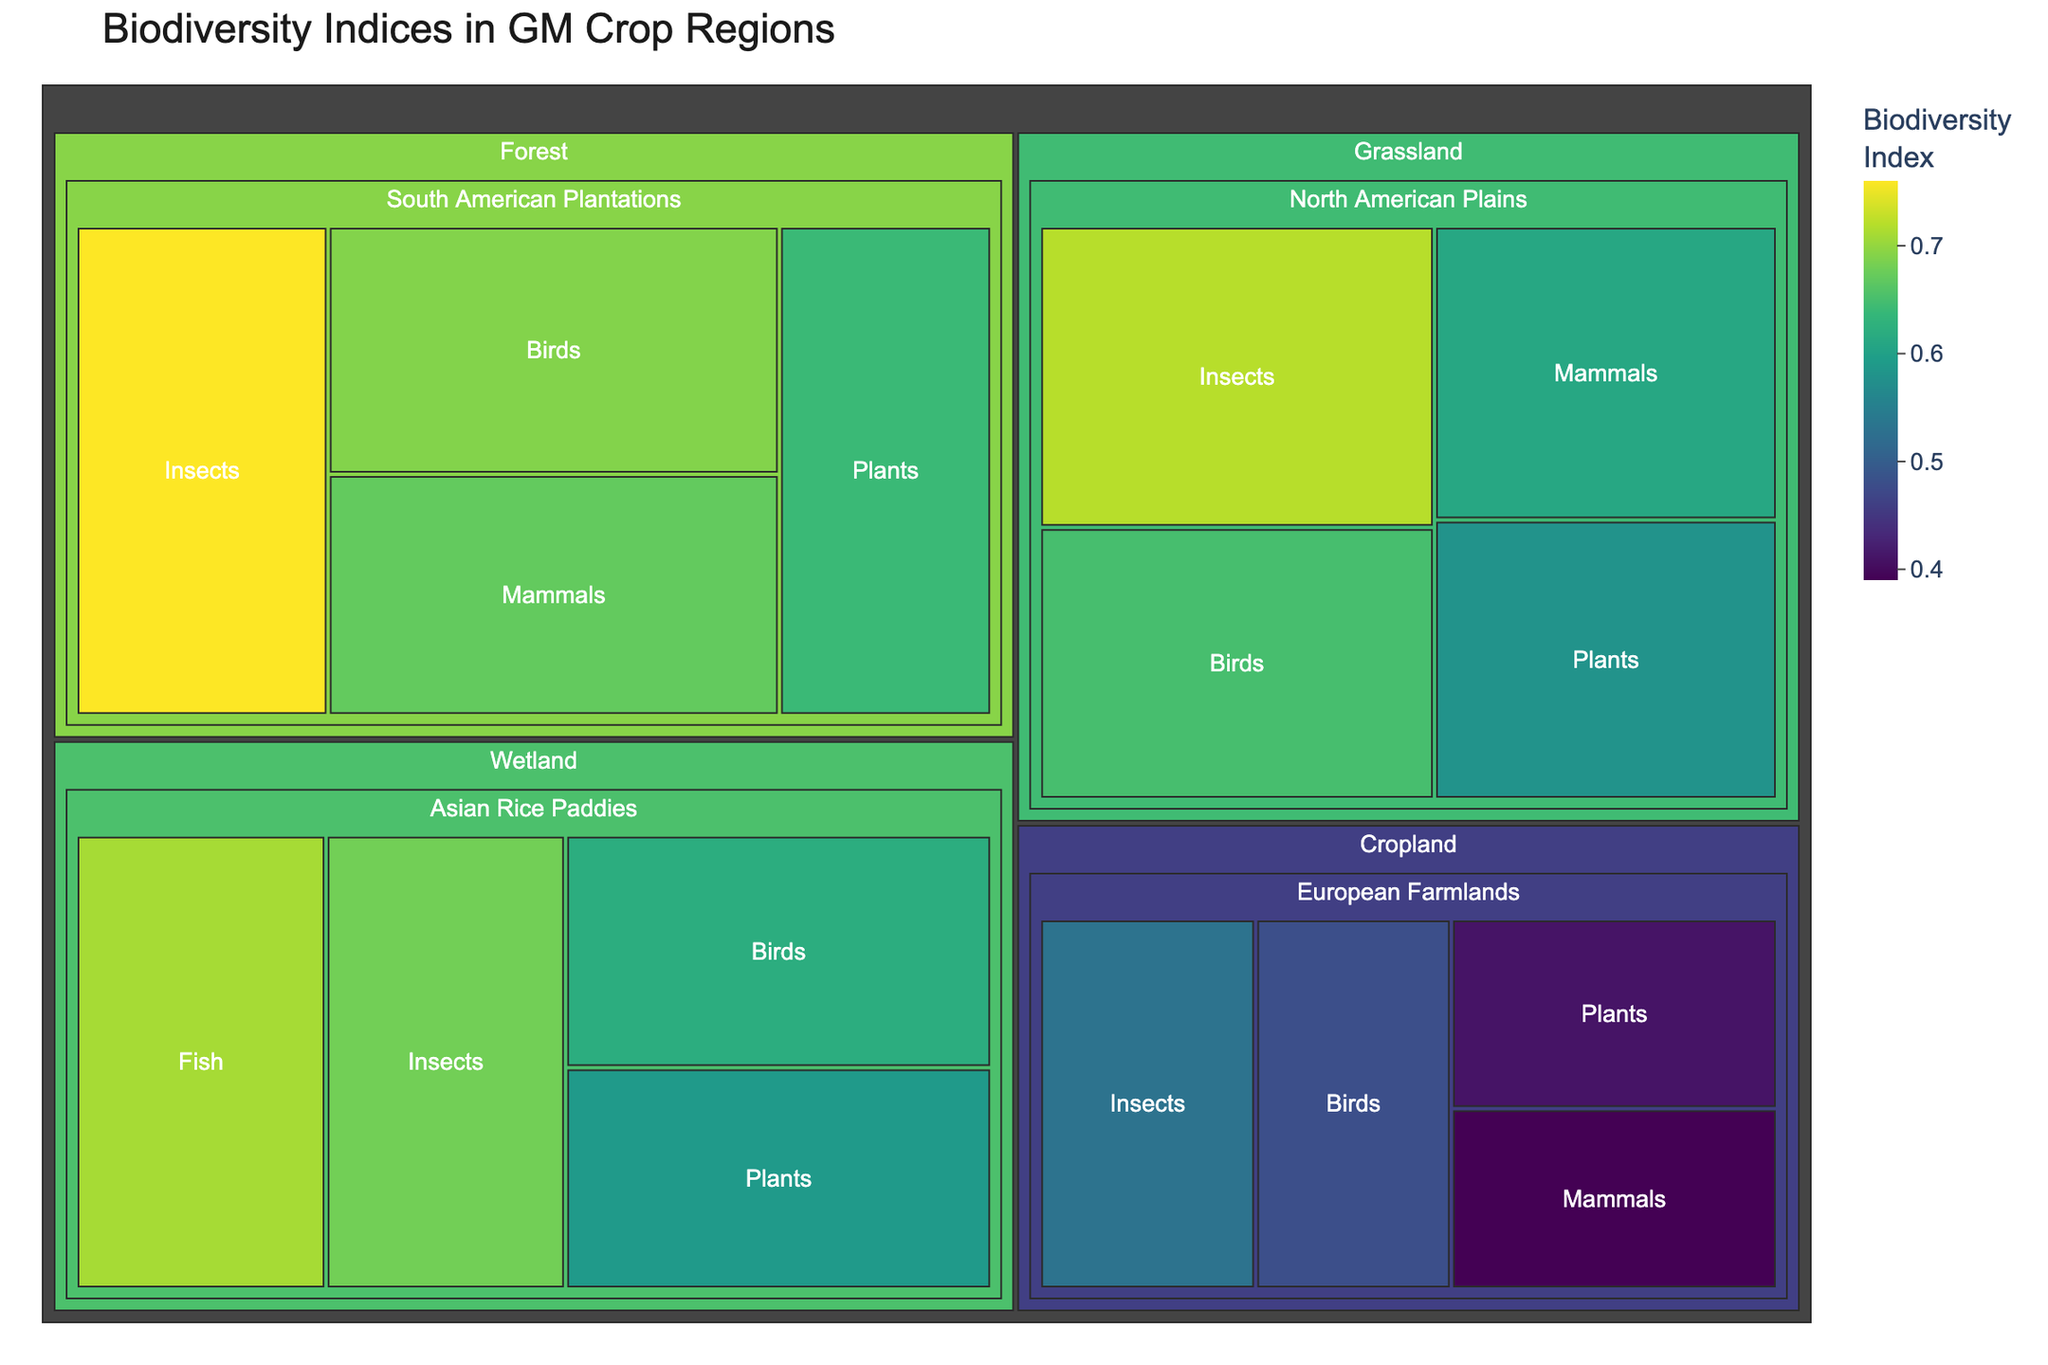What's the title of the treemap? The title of the figure is typically located at the top. By looking at the figure, the title should clearly mention what the visual is about.
Answer: Biodiversity Indices in GM Crop Regions Which ecosystem has the highest biodiversity index for insects? By examining the treemap, look at all the sections corresponding to different ecosystems and their respective biodiversity indices for insects. The section with the highest value represents the answer.
Answer: Forest What is the biodiversity index for birds in the Asian Rice Paddies region? Locate the Wetland ecosystem in the treemap, then find the Asian Rice Paddies region under it, and finally identify the index value for birds within that region.
Answer: 0.62 Compare the biodiversity index of mammals in Grassland and Cropland regions. In which region is it higher? Find the sections for mammals under both Grassland and Cropland ecosystems, and compare their biodiversity indices to determine in which region it is higher.
Answer: Grassland Calculate the difference in biodiversity index for plants between the North American Plains and European Farmlands. Identify the biodiversity index for plants in the North American Plains under Grassland and in the European Farmlands under Cropland. Subtract the latter from the former to find the difference.
Answer: 0.17 Sum the biodiversity indices for all species groups in the Forest ecosystem. Locate the biodiversity indices for all species groups (Insects, Birds, Plants, Mammals) under the Forest ecosystem and add them together.
Answer: 2.76 What is the average biodiversity index for species in the Cropland ecosystem? Find the biodiversity indices for all species groups (Insects, Birds, Plants, Mammals) under Cropland. Calculate the average by summing these values and dividing by the count of species groups.
Answer: 0.4525 Which ecosystem has the lowest biodiversity index overall, and which species group in that ecosystem has the lowest index? Identify the ecosystems in the treemap and their respective biodiversity indices, then find the ecosystem with the lowest overall index. Within that ecosystem, find the species group with the lowest index.
Answer: Cropland; Mammals Are the biodiversity indices for plants in Grassland and Wetland ecosystems higher or lower than 0.6? Locate the biodiversity indices for plants in the Grassland and Wetland ecosystems and check if each value is greater than or less than 0.6.
Answer: Lower; Lower Which species group within the Wetland ecosystem has the highest biodiversity index? Find the sections within the Wetland ecosystem and compare the biodiversity indices for each species group (Insects, Birds, Plants, Fish) to determine the highest value.
Answer: Fish 